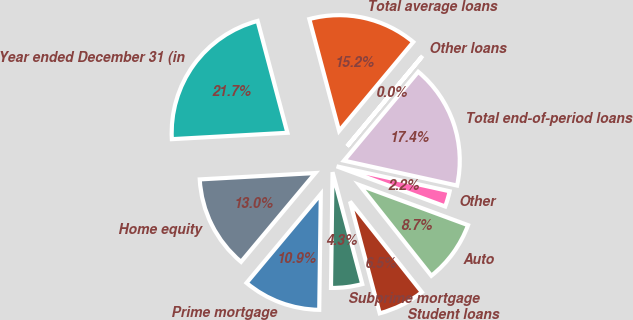Convert chart to OTSL. <chart><loc_0><loc_0><loc_500><loc_500><pie_chart><fcel>Year ended December 31 (in<fcel>Home equity<fcel>Prime mortgage<fcel>Subprime mortgage<fcel>Student loans<fcel>Auto<fcel>Other<fcel>Total end-of-period loans<fcel>Other loans<fcel>Total average loans<nl><fcel>21.73%<fcel>13.04%<fcel>10.87%<fcel>4.35%<fcel>6.53%<fcel>8.7%<fcel>2.18%<fcel>17.38%<fcel>0.01%<fcel>15.21%<nl></chart> 